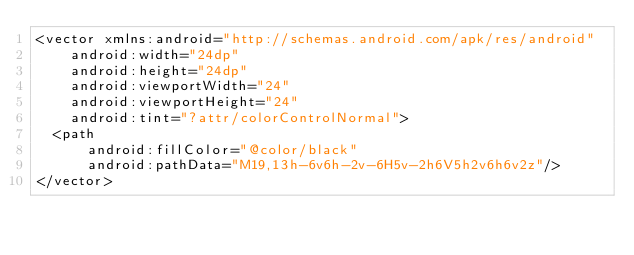<code> <loc_0><loc_0><loc_500><loc_500><_XML_><vector xmlns:android="http://schemas.android.com/apk/res/android"
    android:width="24dp"
    android:height="24dp"
    android:viewportWidth="24"
    android:viewportHeight="24"
    android:tint="?attr/colorControlNormal">
  <path
      android:fillColor="@color/black"
      android:pathData="M19,13h-6v6h-2v-6H5v-2h6V5h2v6h6v2z"/>
</vector>
</code> 